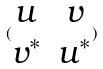<formula> <loc_0><loc_0><loc_500><loc_500>( \begin{matrix} u & v \\ v ^ { * } & u ^ { * } \end{matrix} )</formula> 